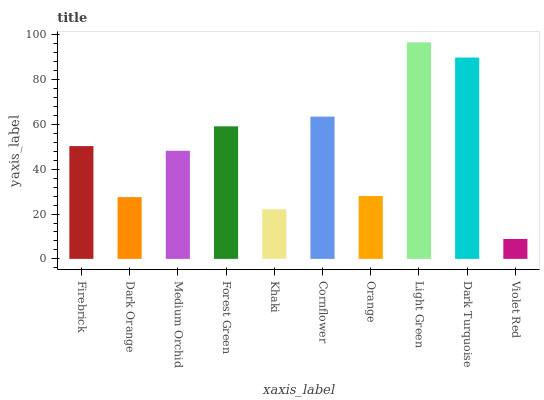Is Dark Orange the minimum?
Answer yes or no. No. Is Dark Orange the maximum?
Answer yes or no. No. Is Firebrick greater than Dark Orange?
Answer yes or no. Yes. Is Dark Orange less than Firebrick?
Answer yes or no. Yes. Is Dark Orange greater than Firebrick?
Answer yes or no. No. Is Firebrick less than Dark Orange?
Answer yes or no. No. Is Firebrick the high median?
Answer yes or no. Yes. Is Medium Orchid the low median?
Answer yes or no. Yes. Is Orange the high median?
Answer yes or no. No. Is Light Green the low median?
Answer yes or no. No. 